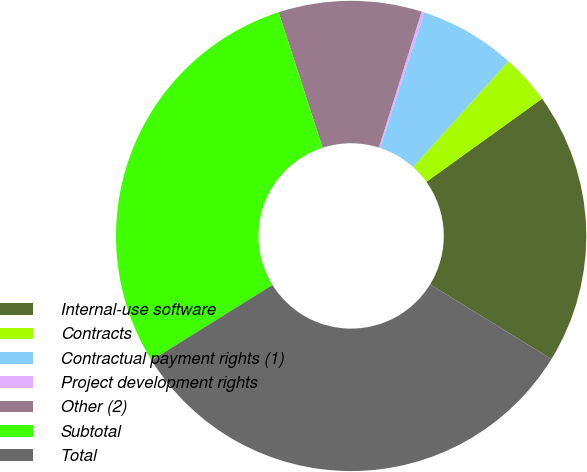Convert chart. <chart><loc_0><loc_0><loc_500><loc_500><pie_chart><fcel>Internal-use software<fcel>Contracts<fcel>Contractual payment rights (1)<fcel>Project development rights<fcel>Other (2)<fcel>Subtotal<fcel>Total<nl><fcel>18.69%<fcel>3.41%<fcel>6.63%<fcel>0.19%<fcel>9.84%<fcel>28.88%<fcel>32.37%<nl></chart> 